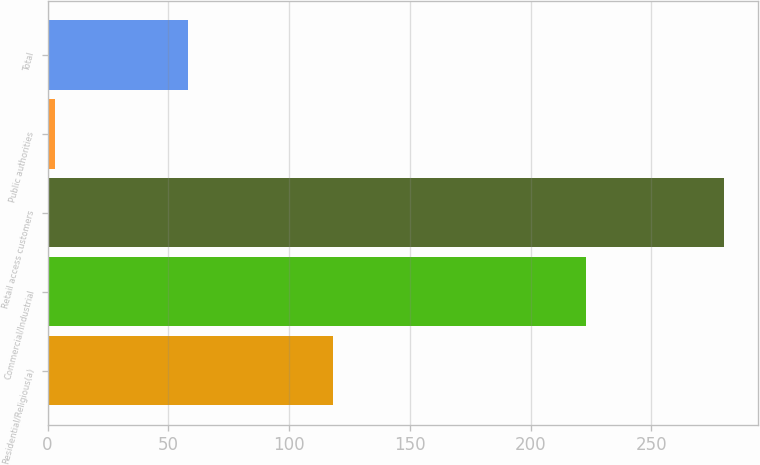Convert chart to OTSL. <chart><loc_0><loc_0><loc_500><loc_500><bar_chart><fcel>Residential/Religious(a)<fcel>Commercial/Industrial<fcel>Retail access customers<fcel>Public authorities<fcel>Total<nl><fcel>118<fcel>223<fcel>280<fcel>3<fcel>58<nl></chart> 